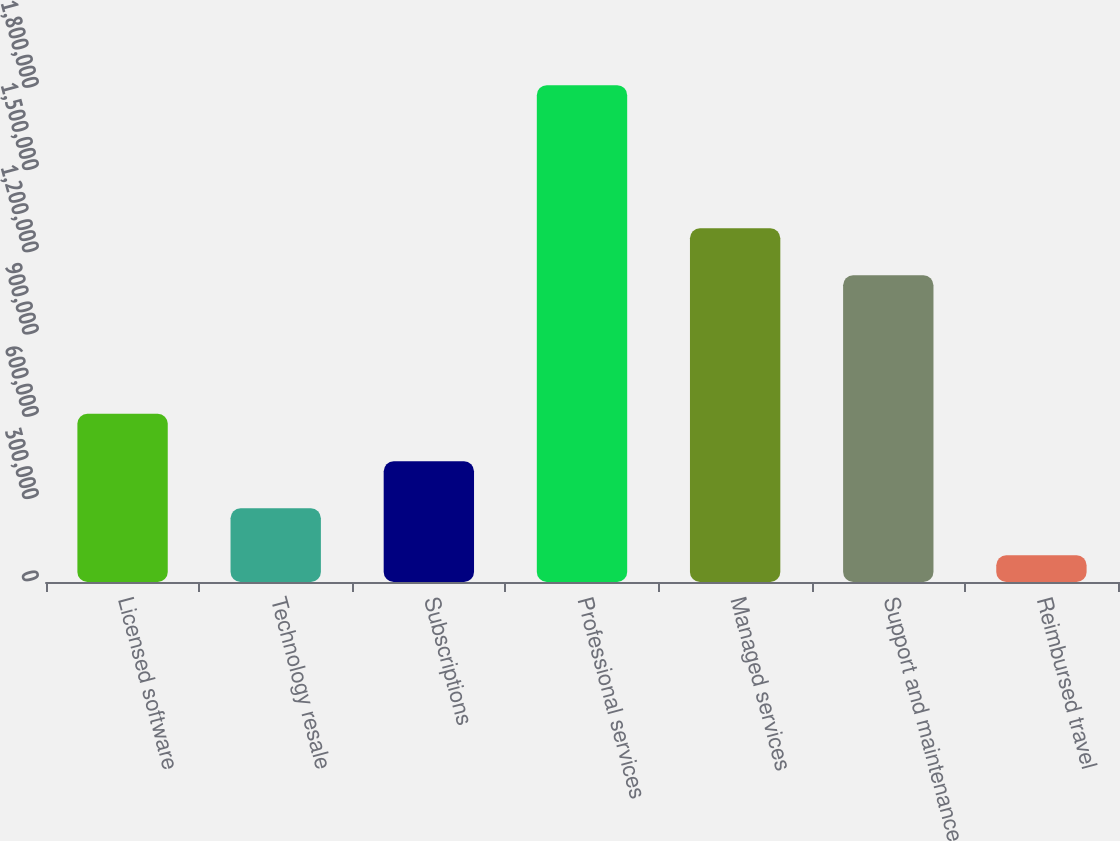<chart> <loc_0><loc_0><loc_500><loc_500><bar_chart><fcel>Licensed software<fcel>Technology resale<fcel>Subscriptions<fcel>Professional services<fcel>Managed services<fcel>Support and maintenance<fcel>Reimbursed travel<nl><fcel>613578<fcel>268844<fcel>440246<fcel>1.81146e+06<fcel>1.28952e+06<fcel>1.11812e+06<fcel>97442<nl></chart> 